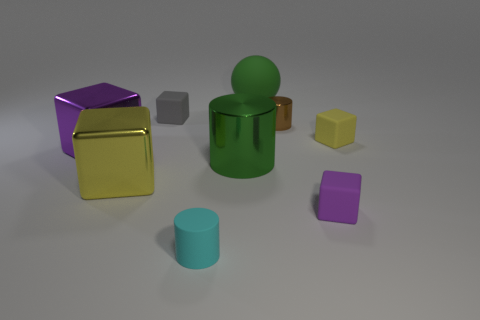What time of day does the lighting in this scene suggest? The soft shadows and even lighting in the scene suggest an indoor setting, probably illuminated by artificial light sources rather than natural light, which indicates no specific time of day. 